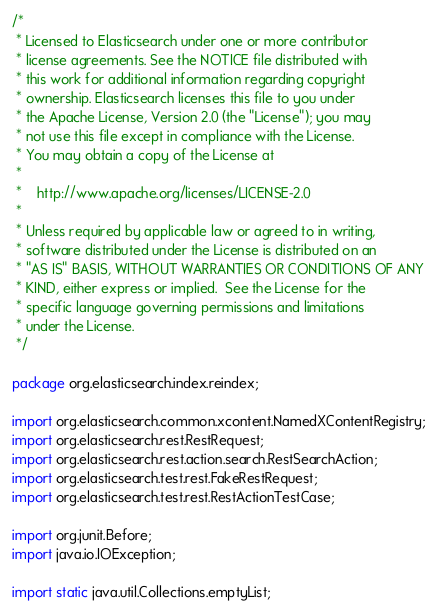<code> <loc_0><loc_0><loc_500><loc_500><_Java_>/*
 * Licensed to Elasticsearch under one or more contributor
 * license agreements. See the NOTICE file distributed with
 * this work for additional information regarding copyright
 * ownership. Elasticsearch licenses this file to you under
 * the Apache License, Version 2.0 (the "License"); you may
 * not use this file except in compliance with the License.
 * You may obtain a copy of the License at
 *
 *    http://www.apache.org/licenses/LICENSE-2.0
 *
 * Unless required by applicable law or agreed to in writing,
 * software distributed under the License is distributed on an
 * "AS IS" BASIS, WITHOUT WARRANTIES OR CONDITIONS OF ANY
 * KIND, either express or implied.  See the License for the
 * specific language governing permissions and limitations
 * under the License.
 */

package org.elasticsearch.index.reindex;

import org.elasticsearch.common.xcontent.NamedXContentRegistry;
import org.elasticsearch.rest.RestRequest;
import org.elasticsearch.rest.action.search.RestSearchAction;
import org.elasticsearch.test.rest.FakeRestRequest;
import org.elasticsearch.test.rest.RestActionTestCase;

import org.junit.Before;
import java.io.IOException;

import static java.util.Collections.emptyList;
</code> 